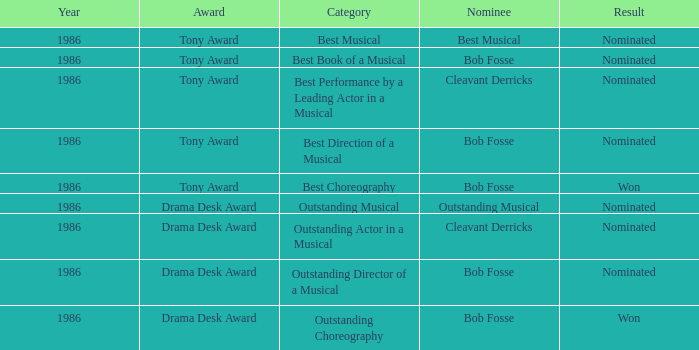Which award has the category of the best direction of a musical? Tony Award. 